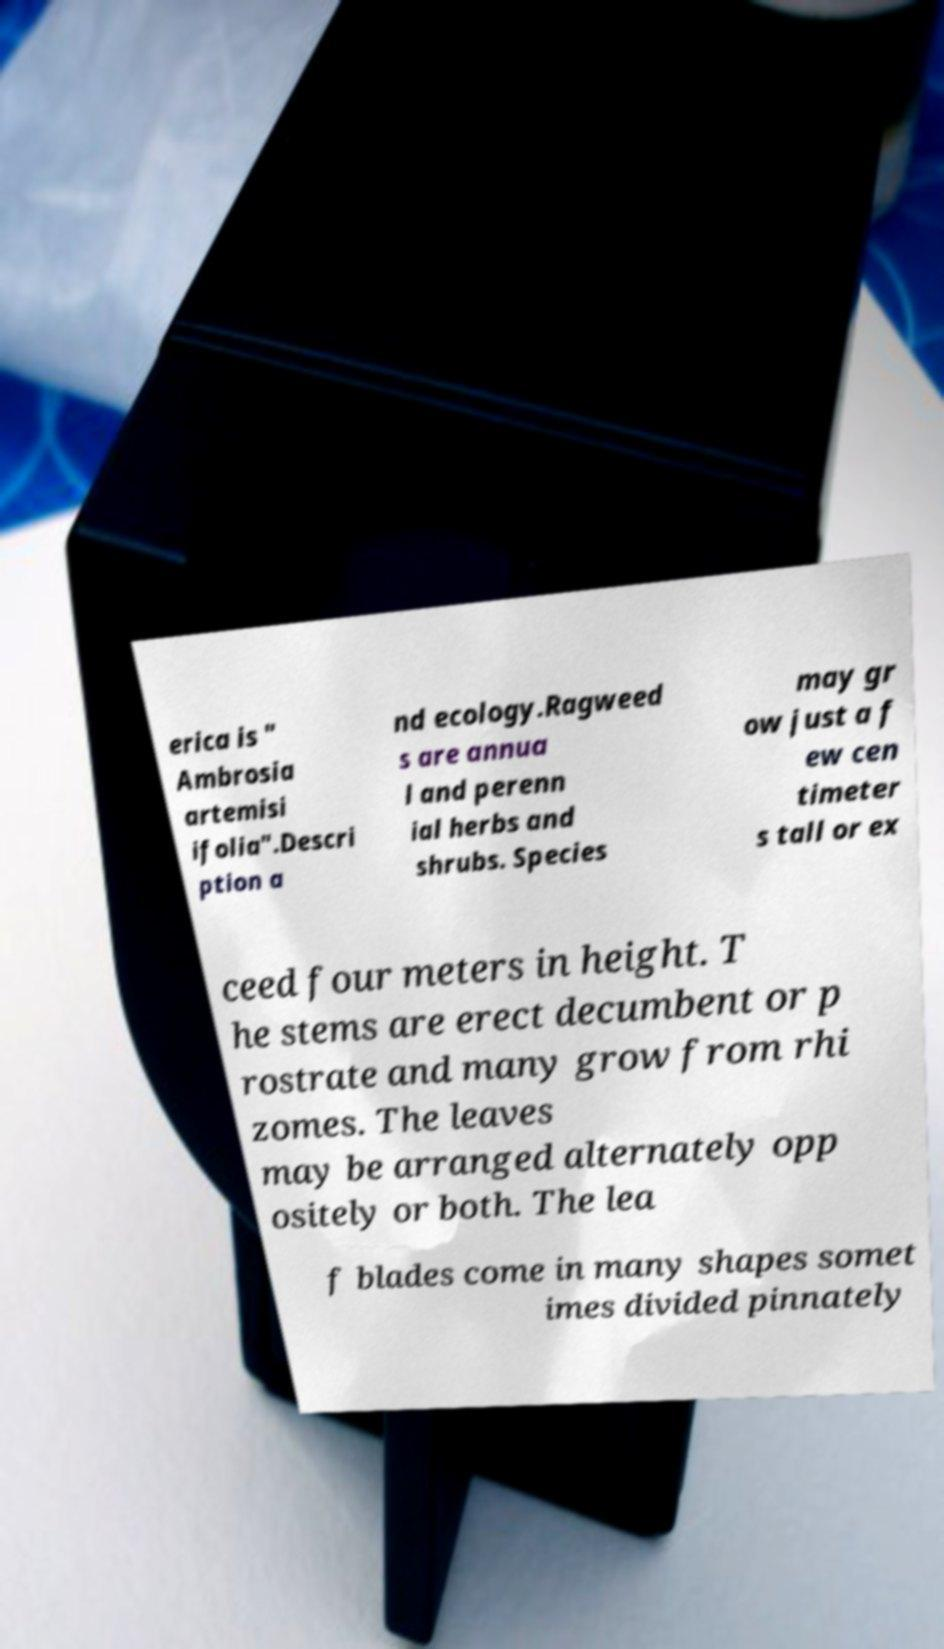Can you accurately transcribe the text from the provided image for me? erica is " Ambrosia artemisi ifolia".Descri ption a nd ecology.Ragweed s are annua l and perenn ial herbs and shrubs. Species may gr ow just a f ew cen timeter s tall or ex ceed four meters in height. T he stems are erect decumbent or p rostrate and many grow from rhi zomes. The leaves may be arranged alternately opp ositely or both. The lea f blades come in many shapes somet imes divided pinnately 